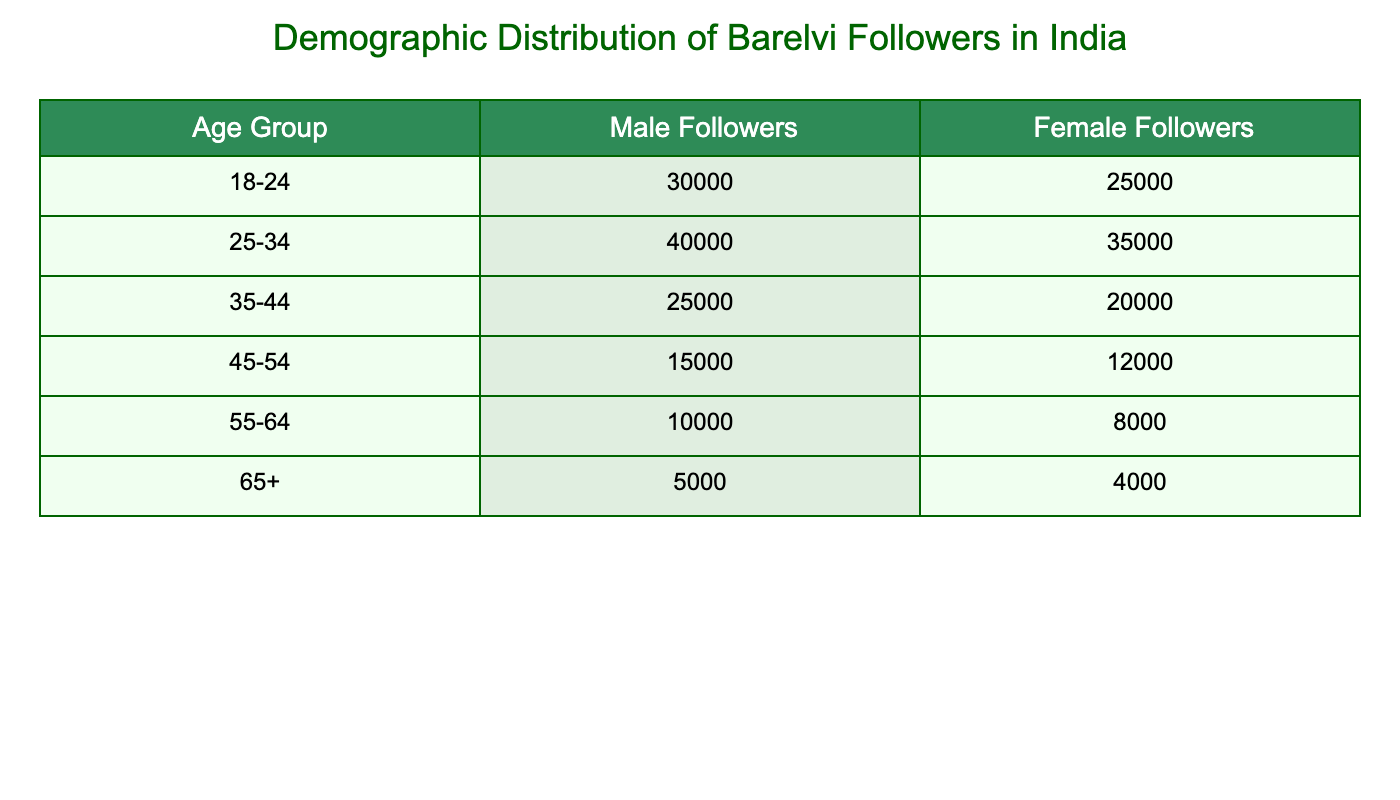What is the total number of male followers aged 25-34? The table shows that there are 40,000 male followers in the age group of 25-34.
Answer: 40,000 What is the combined total number of female followers across all age groups? To find the combined total, we sum the female followers from each age group: 25,000 + 35,000 + 20,000 + 12,000 + 8,000 + 4,000 = 104,000.
Answer: 104,000 Are there more female followers in the age group 45-54 than in the age group 55-64? In the age group 45-54, there are 12,000 female followers, while in the age group 55-64, there are 8,000 female followers. Since 12,000 is greater than 8,000, the statement is true.
Answer: Yes What is the average number of male followers in the age group 18-24 and 35-44? First, find the number of male followers in both age groups: 30,000 (18-24) + 25,000 (35-44) = 55,000. There are 2 age groups, so the average is 55,000/2 = 27,500.
Answer: 27,500 How many more female followers are there in the age group 25-34 compared to the age group 45-54? The age group 25-34 has 35,000 female followers, while the group 45-54 has 12,000. To find the difference, we calculate 35,000 - 12,000 = 23,000.
Answer: 23,000 Is it true that the number of male followers decreases as the age groups increase? By examining the table, we see the male followers: 30,000 (18-24), 40,000 (25-34), 25,000 (35-44), 15,000 (45-54), 10,000 (55-64), and 5,000 (65+). The numbers do not consistently decrease. Therefore, the statement is false.
Answer: No What percentage of the total male followers belong to the age group 65+? First, calculate the total number of male followers: 30,000 + 40,000 + 25,000 + 15,000 + 10,000 + 5,000 = 125,000. The number of male followers in the age group 65+ is 5,000. Thus, the percentage is (5,000/125,000) * 100 = 4%.
Answer: 4% Which age group has the highest number of female followers and how many are there? The age group 25-34 has the highest number of female followers with a total of 35,000.
Answer: 25-34, 35,000 In the 55-64 age group, what is the ratio of male to female followers? In the 55-64 age group, there are 10,000 male followers and 8,000 female followers. The ratio is 10,000:8,000, which simplifies to 5:4.
Answer: 5:4 